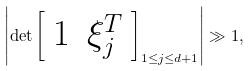Convert formula to latex. <formula><loc_0><loc_0><loc_500><loc_500>\left | \det \left [ \begin{array} { c c } 1 & \xi ^ { T } _ { j } \end{array} \right ] _ { 1 \leq j \leq d + 1 } \right | \gg 1 ,</formula> 